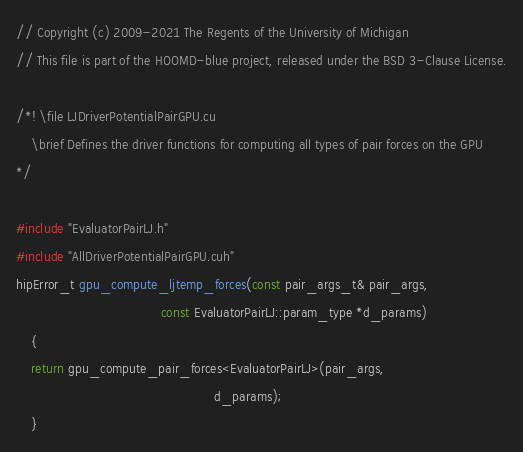<code> <loc_0><loc_0><loc_500><loc_500><_Cuda_>// Copyright (c) 2009-2021 The Regents of the University of Michigan
// This file is part of the HOOMD-blue project, released under the BSD 3-Clause License.

/*! \file LJDriverPotentialPairGPU.cu
    \brief Defines the driver functions for computing all types of pair forces on the GPU
*/

#include "EvaluatorPairLJ.h"
#include "AllDriverPotentialPairGPU.cuh"
hipError_t gpu_compute_ljtemp_forces(const pair_args_t& pair_args,
                                      const EvaluatorPairLJ::param_type *d_params)
    {
    return gpu_compute_pair_forces<EvaluatorPairLJ>(pair_args,
                                                    d_params);
    }


</code> 